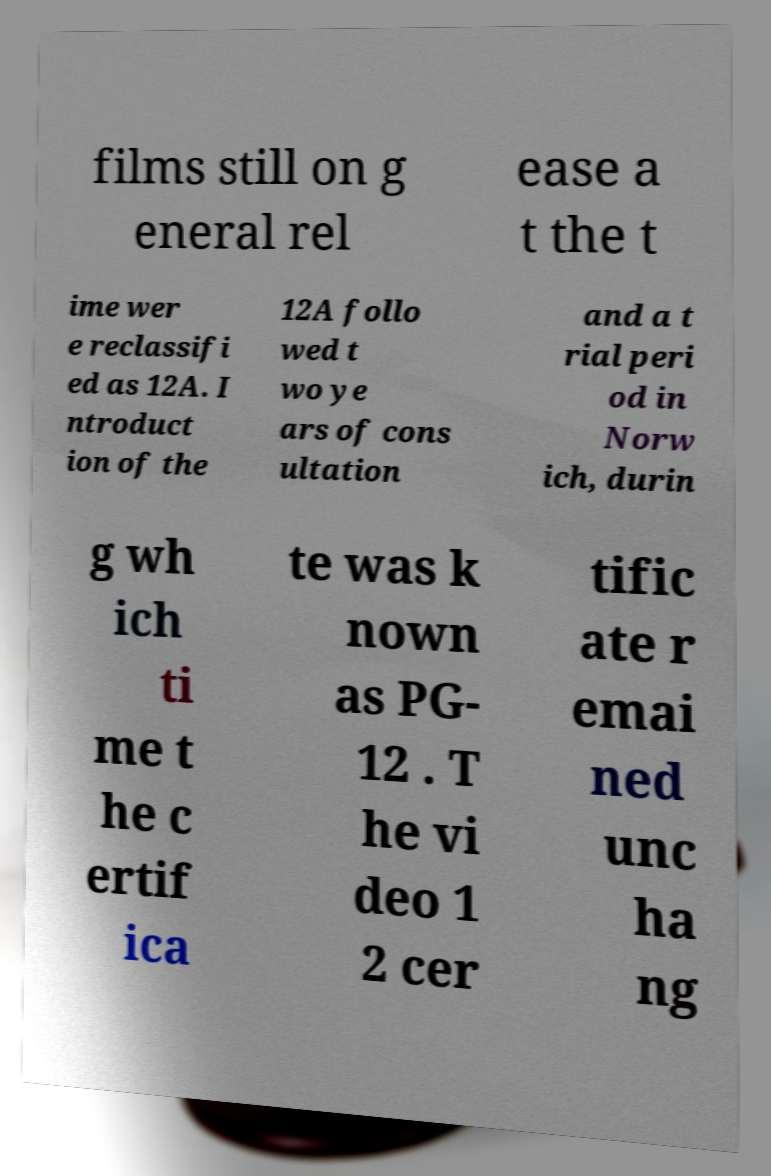Can you read and provide the text displayed in the image?This photo seems to have some interesting text. Can you extract and type it out for me? films still on g eneral rel ease a t the t ime wer e reclassifi ed as 12A. I ntroduct ion of the 12A follo wed t wo ye ars of cons ultation and a t rial peri od in Norw ich, durin g wh ich ti me t he c ertif ica te was k nown as PG- 12 . T he vi deo 1 2 cer tific ate r emai ned unc ha ng 